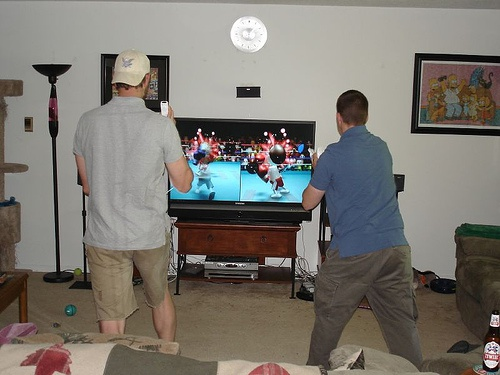Describe the objects in this image and their specific colors. I can see people in gray and darkgray tones, people in gray and black tones, tv in gray, black, and lightblue tones, couch in gray, darkgray, and tan tones, and couch in gray, black, and darkgreen tones in this image. 